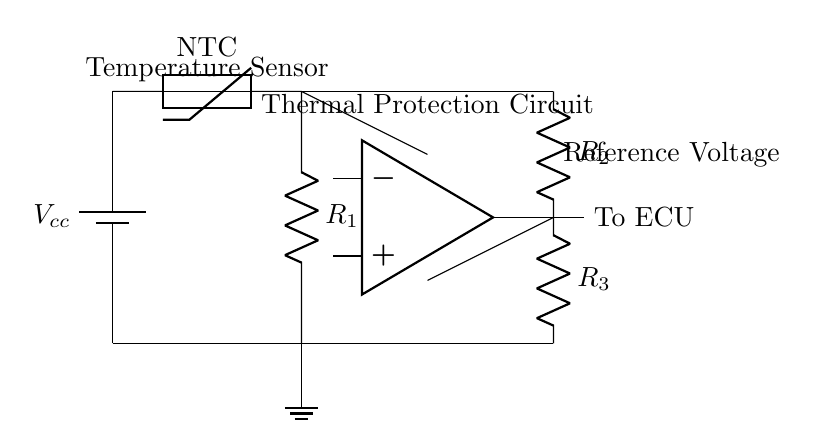What type of thermistor is used in this circuit? The diagram labels the thermistor as NTC, which stands for negative temperature coefficient, indicating it decreases resistance as temperature increases.
Answer: NTC What is the purpose of the comparator in this circuit? The comparator compares the voltage from the thermistor with the reference voltage set by the resistors in the voltage divider, determining if the ECU should be activated for thermal protection.
Answer: To compare voltages What does the reference voltage consist of? The reference voltage is derived from a voltage divider created by resistors R2 and R3, which determines the threshold for the comparator's operation.
Answer: Resistors R2 and R3 How many resistors are present in the circuit? There are two resistors in the main circuit: R1 (connected to the thermistor) and the pair R2 and R3 (forming the voltage divider). Therefore, the total count is three.
Answer: Three What indicates that this circuit provides thermal protection? The presence of the thermistor, which senses temperature, combined with the comparator that activates the ECU based on the thermistor's output, indicates thermal protection.
Answer: Thermistor and comparator What is the output of the thermal protection circuit? The output of the thermal protection circuit is directed to the ECU, indicating that it will either engage or disengage based on thermal conditions.
Answer: To ECU 